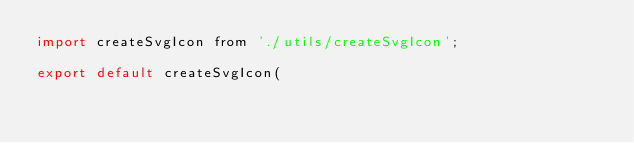Convert code to text. <code><loc_0><loc_0><loc_500><loc_500><_JavaScript_>import createSvgIcon from './utils/createSvgIcon';

export default createSvgIcon(</code> 